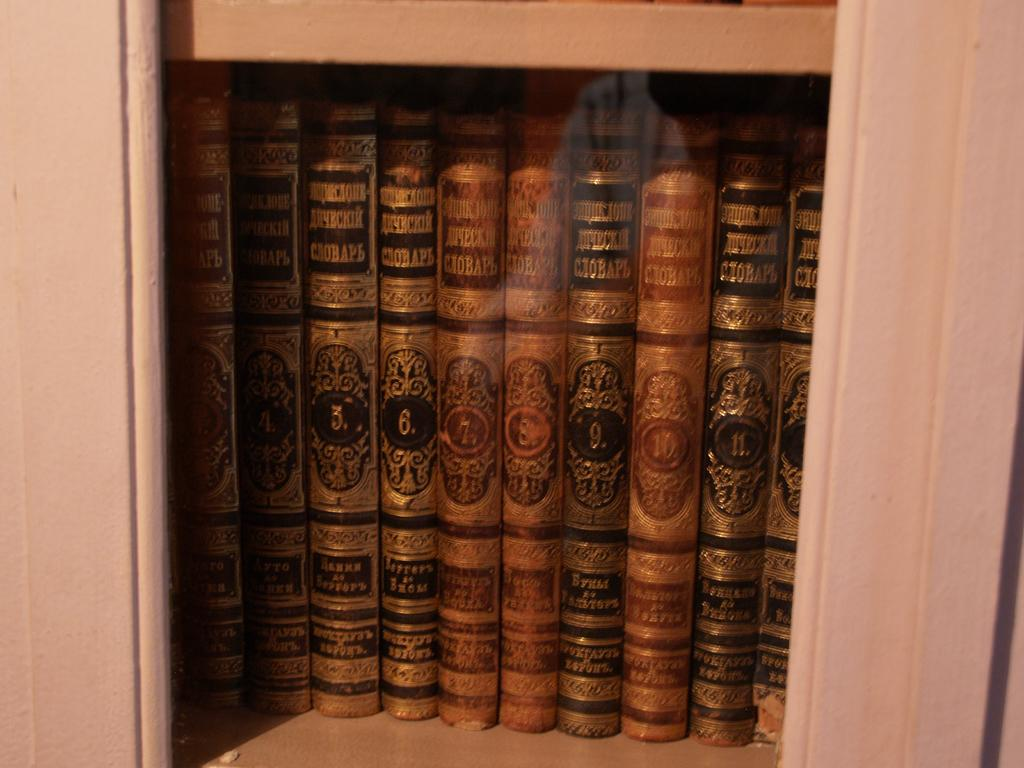What can be seen arranged in a row in the middle of the image? There are objects arranged in a row in the middle of the image, which resemble books on a shelf. How are the objects arranged in the image? The objects are arranged in a row, suggesting they might be on a shelf or similar surface. What type of pipe can be seen in the image? There is no pipe present in the image; it features objects arranged in a row that resemble books on a shelf. 